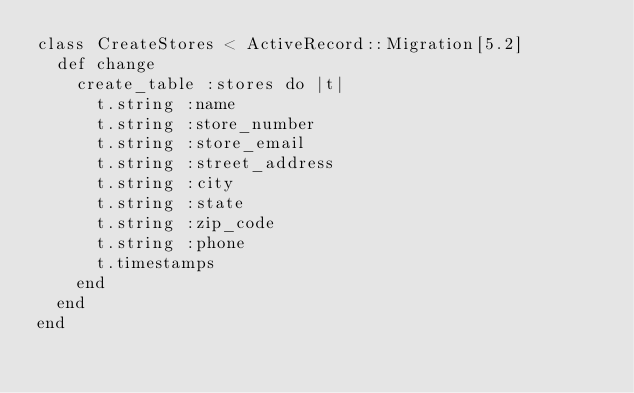<code> <loc_0><loc_0><loc_500><loc_500><_Ruby_>class CreateStores < ActiveRecord::Migration[5.2]
  def change
    create_table :stores do |t|
      t.string :name
      t.string :store_number
      t.string :store_email
      t.string :street_address
      t.string :city
      t.string :state
      t.string :zip_code
      t.string :phone
      t.timestamps
    end
  end
end
</code> 